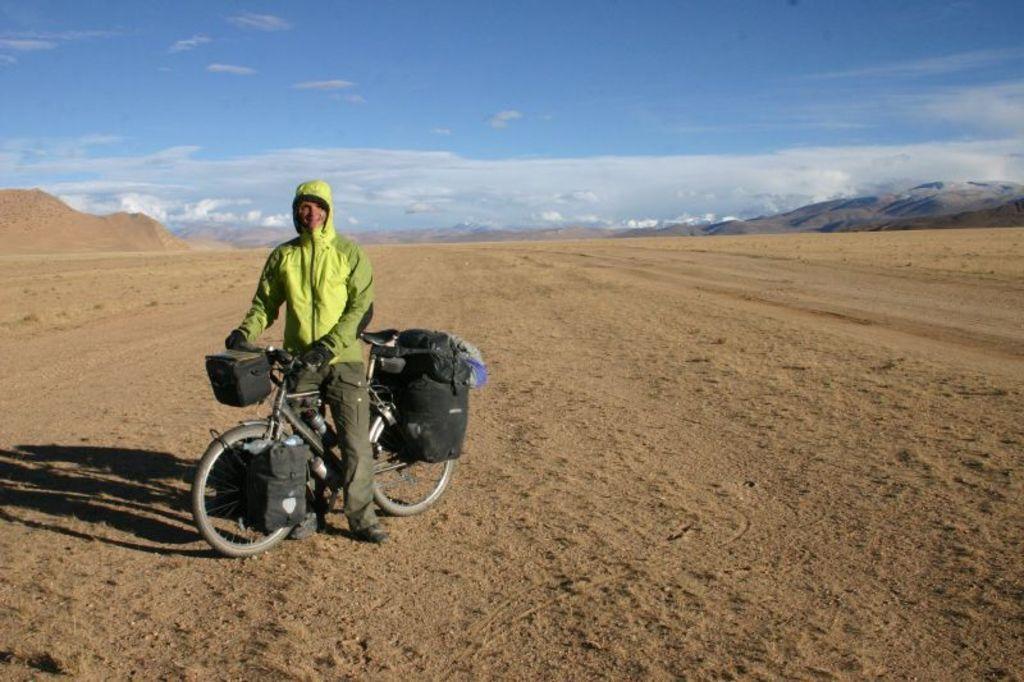How would you summarize this image in a sentence or two? In this image there is a person standing on the bicycle, which is on the surface of the sand and there are few bags hanging on it. In the background there are mountains and the sky. 